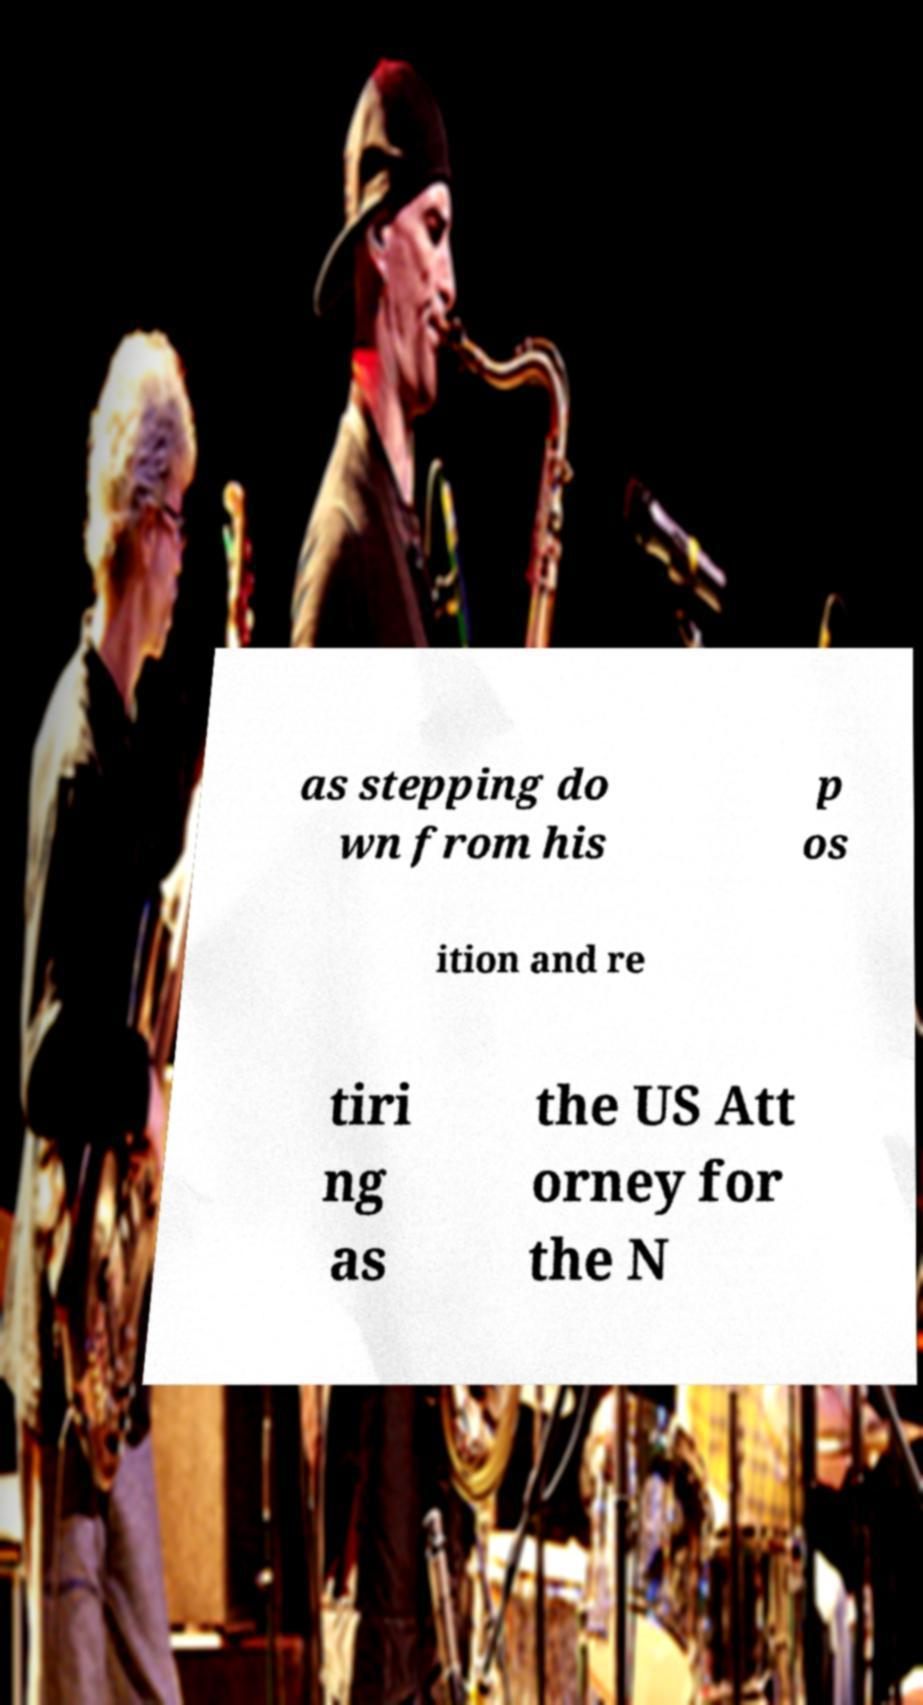I need the written content from this picture converted into text. Can you do that? as stepping do wn from his p os ition and re tiri ng as the US Att orney for the N 